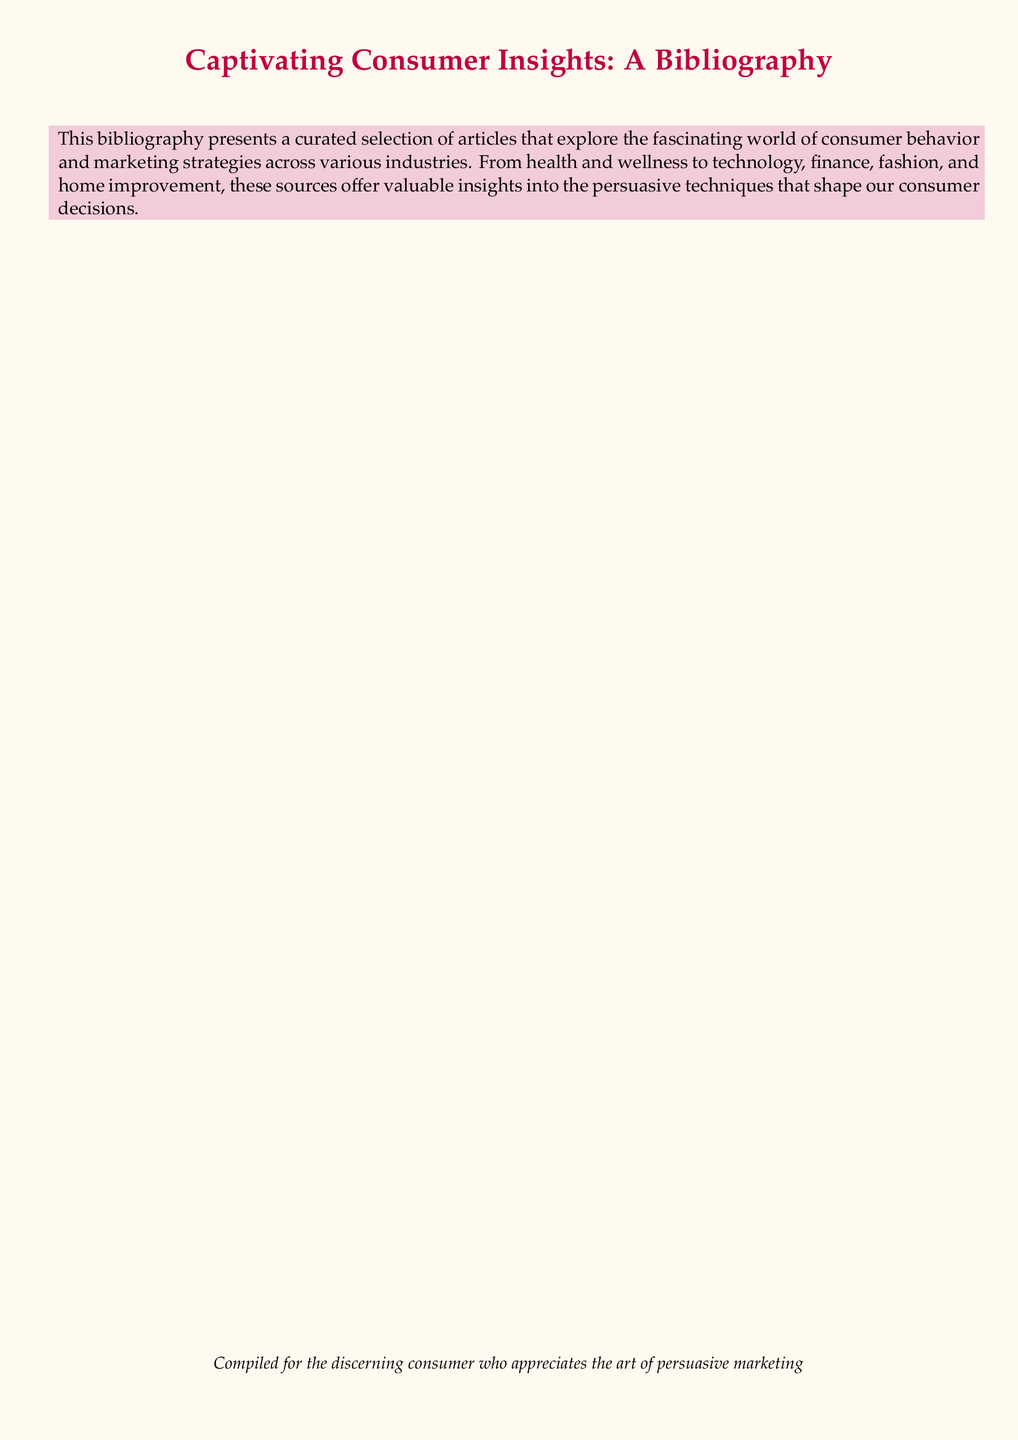What is the title of the first article? The title is specified at the beginning of the bibliography, listed as the first entry.
Answer: An In-Depth Analysis of Health and Wellness Products: Featuring persuasive marketing trends and best-performing brands Who is the author of the second article? The author can be found in the citation for the second article listed in the bibliography.
Answer: Johnson, Emma In what year was the third article published? The year of publication for each article is noted in the citations, specifically for the third one.
Answer: 2021 What is the name of the journal where the first article was published? The journal title is provided alongside the citation for the first entry in the bibliography.
Answer: Journal of Consumer Marketing Which article discusses marketing messages in the context of home improvement? The title of the relevant article mentions home improvement and persuasive marketing.
Answer: Home Improvement and Smart Living Solutions: A look into the most persuasive marketing messages driving consumer interest in modern home upgrades How many articles are included in the bibliography? The total number of articles is determined by counting the entries listed in the document.
Answer: Five What marketing aspect is explored in the fourth article? The specific focus is indicated in the title of the fourth entry regarding the interaction of marketing with consumer preferences.
Answer: Fashion trends Which publication features the article by Sophia Williams? The citation of the article indicates where it was published.
Answer: Vogue What is the purpose of the compiled bibliography? The purpose is described in the context provided at the beginning of the document.
Answer: To explore the fascinating world of consumer behavior and marketing strategies 